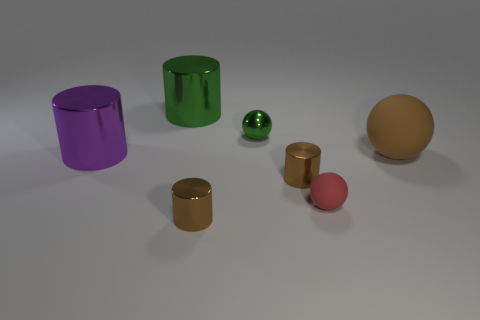Add 1 small shiny spheres. How many objects exist? 8 Subtract all spheres. How many objects are left? 4 Subtract all cylinders. Subtract all big metal objects. How many objects are left? 1 Add 3 green things. How many green things are left? 5 Add 6 big green cylinders. How many big green cylinders exist? 7 Subtract 1 brown balls. How many objects are left? 6 